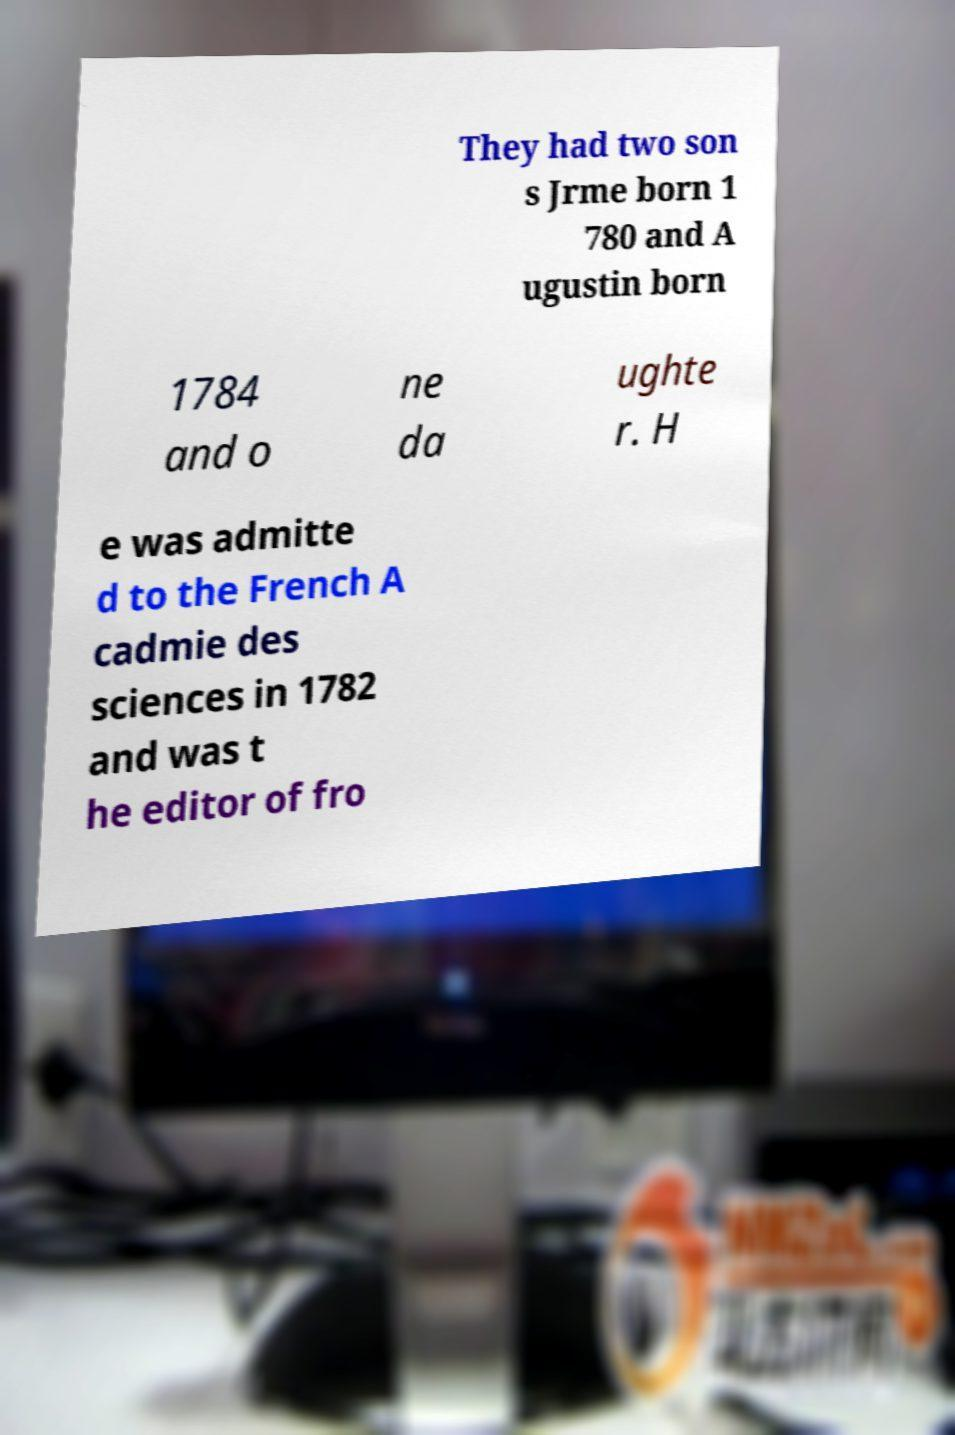Please read and relay the text visible in this image. What does it say? They had two son s Jrme born 1 780 and A ugustin born 1784 and o ne da ughte r. H e was admitte d to the French A cadmie des sciences in 1782 and was t he editor of fro 